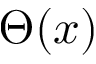Convert formula to latex. <formula><loc_0><loc_0><loc_500><loc_500>\Theta ( x )</formula> 